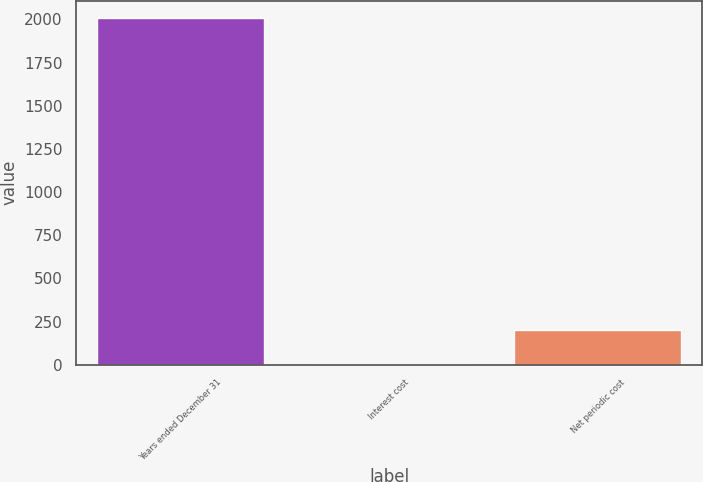Convert chart to OTSL. <chart><loc_0><loc_0><loc_500><loc_500><bar_chart><fcel>Years ended December 31<fcel>Interest cost<fcel>Net periodic cost<nl><fcel>2008<fcel>3.2<fcel>203.68<nl></chart> 